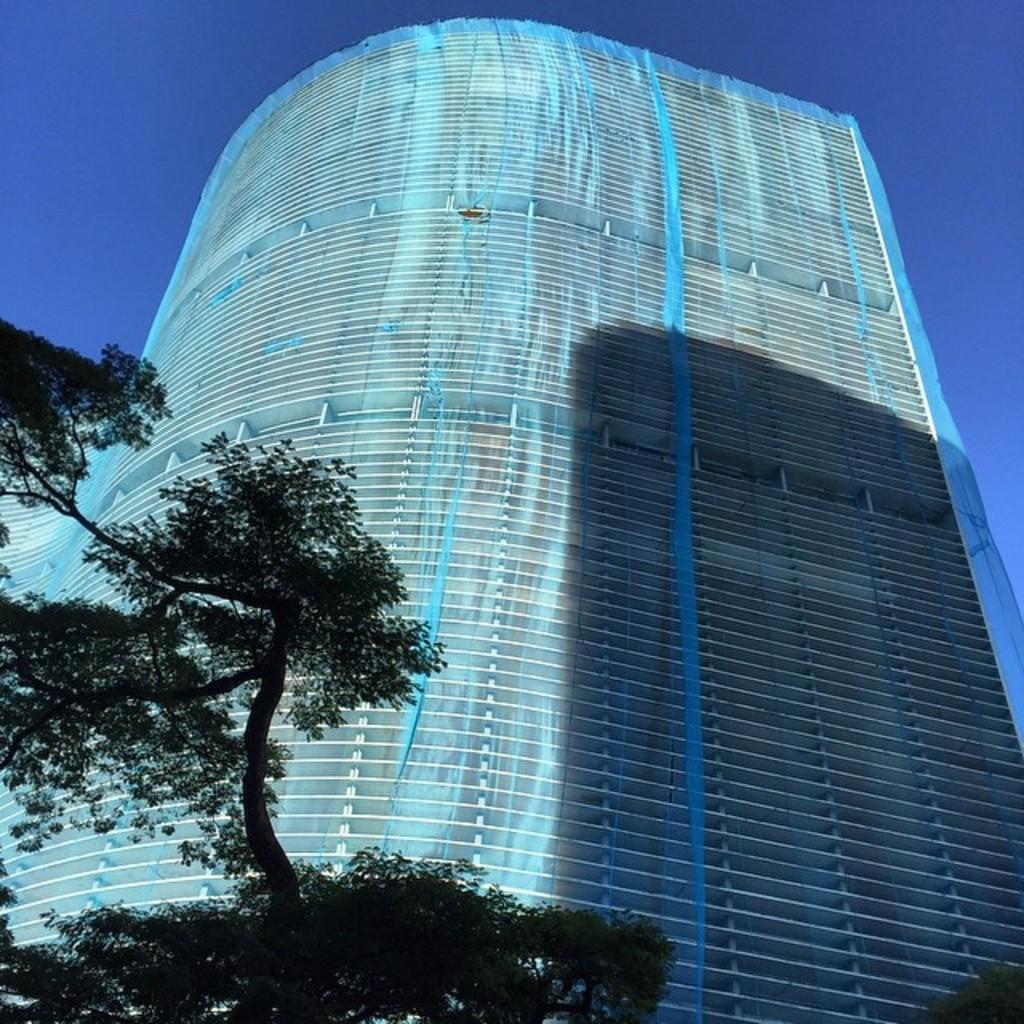Can you describe this image briefly? In the picture we can see a tree and behind it, we can see the tall building with many floors and on the top of it we can see a part of the sky. 